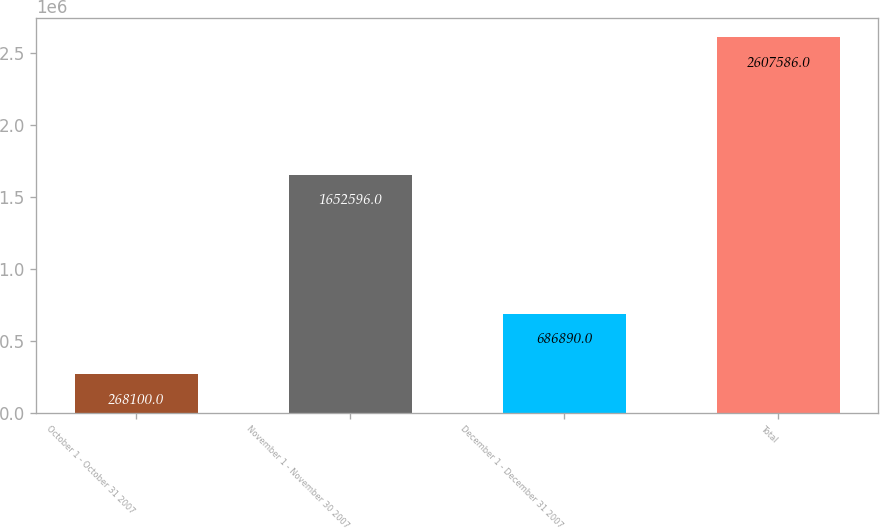<chart> <loc_0><loc_0><loc_500><loc_500><bar_chart><fcel>October 1 - October 31 2007<fcel>November 1 - November 30 2007<fcel>December 1 - December 31 2007<fcel>Total<nl><fcel>268100<fcel>1.6526e+06<fcel>686890<fcel>2.60759e+06<nl></chart> 